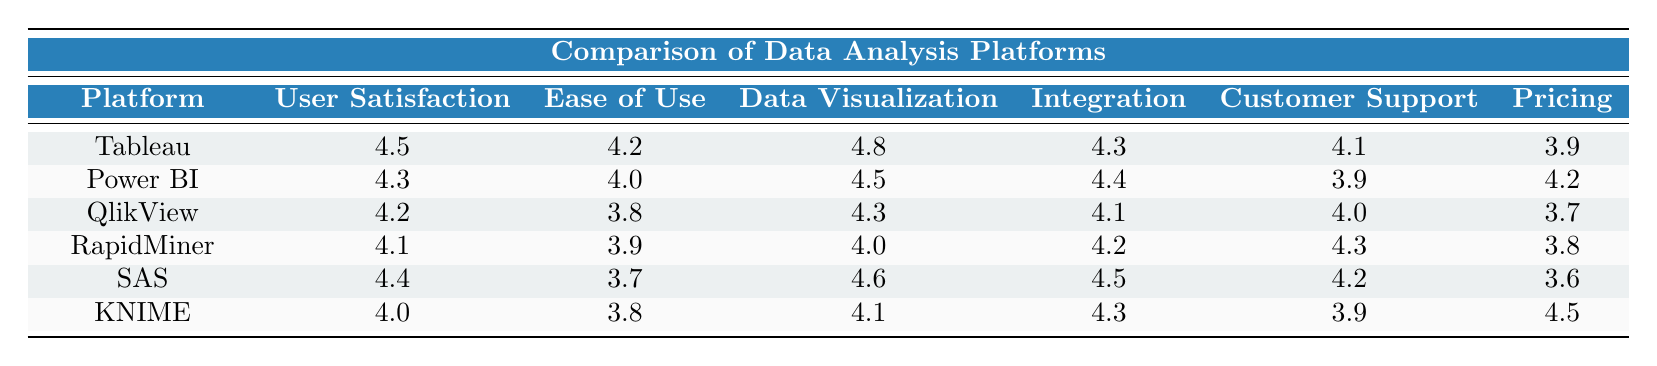What is the user satisfaction rating for Tableau? The table shows the user satisfaction rating for Tableau listed under the "User Satisfaction" column. It is directly next to the name "Tableau," which indicates a rating of 4.5.
Answer: 4.5 Which platform has the highest data visualization rating? By examining the "Data Visualization" column, Tableau has a rating of 4.8, which is higher than the other platforms listed.
Answer: Tableau What is the ease of use rating for SAS? To find the ease of use rating for SAS, we look at the "Ease of Use" column next to SAS in the table, which shows a rating of 3.7.
Answer: 3.7 Is customer support for Power BI rated higher than that for RapidMiner? The customer support ratings for Power BI and RapidMiner are 3.9 and 4.3, respectively. Since 3.9 is not higher than 4.3, the statement is false.
Answer: No What is the average user satisfaction rating for all platforms? To find the average, add all the user satisfaction ratings: (4.5 + 4.3 + 4.2 + 4.1 + 4.4 + 4.0) = 25.5. There are 6 platforms, so the average is 25.5 / 6 = 4.25.
Answer: 4.25 Which platform has the best integration capabilities rating? By comparing the "Integration" ratings in the table, SAS has the highest rating of 4.5.
Answer: SAS How much higher is the pricing satisfaction of KNIME compared to QlikView? The pricing satisfaction ratings are 4.5 for KNIME and 3.7 for QlikView. The difference is 4.5 - 3.7 = 0.8.
Answer: 0.8 Does any platform have a higher ease of use rating than 4.5? Looking through the "Ease of Use" column, no platform has a rating higher than 4.5; the highest is 4.2 for Tableau. Thus, the answer is no.
Answer: No What is the difference between the data visualization ratings of Tableau and SAS? Tableau has a data visualization rating of 4.8 and SAS has a rating of 4.6. The difference is 4.8 - 4.6 = 0.2.
Answer: 0.2 